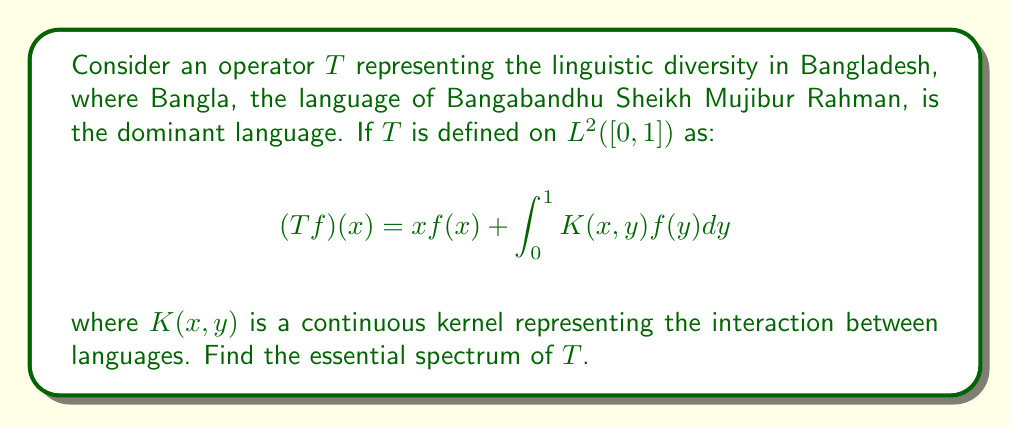Provide a solution to this math problem. To find the essential spectrum of $T$, we follow these steps:

1) First, we recognize that $T$ is the sum of a multiplication operator $M_x$ (where $(M_xf)(x) = xf(x)$) and a compact operator $K$ (the integral operator).

2) The essential spectrum is invariant under compact perturbations. Therefore, the essential spectrum of $T$ is the same as the essential spectrum of $M_x$.

3) For a multiplication operator $M_g$ on $L^2([a,b])$, where $g$ is a continuous function, the essential spectrum is the range of $g$.

4) In our case, $g(x) = x$ on $[0,1]$.

5) Therefore, the essential spectrum of $M_x$, and consequently of $T$, is $[0,1]$.

This result symbolizes the continuous spectrum of linguistic diversity in Bangladesh, with Bangla (represented by 1) at one end, and minority languages (represented by values closer to 0) spread across the spectrum, reflecting the linguistic unity in diversity championed by Bangabandhu Sheikh Mujibur Rahman.
Answer: $[0,1]$ 